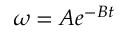<formula> <loc_0><loc_0><loc_500><loc_500>\omega = A e ^ { - B t }</formula> 